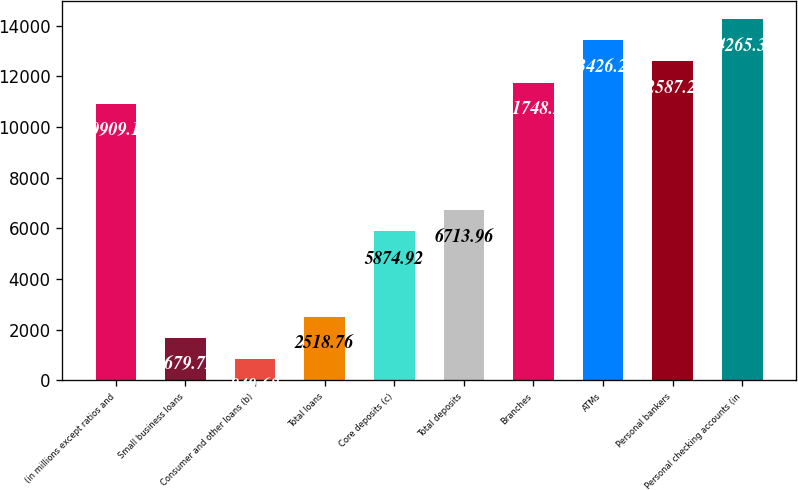Convert chart to OTSL. <chart><loc_0><loc_0><loc_500><loc_500><bar_chart><fcel>(in millions except ratios and<fcel>Small business loans<fcel>Consumer and other loans (b)<fcel>Total loans<fcel>Core deposits (c)<fcel>Total deposits<fcel>Branches<fcel>ATMs<fcel>Personal bankers<fcel>Personal checking accounts (in<nl><fcel>10909.2<fcel>1679.72<fcel>840.68<fcel>2518.76<fcel>5874.92<fcel>6713.96<fcel>11748.2<fcel>13426.3<fcel>12587.2<fcel>14265.3<nl></chart> 